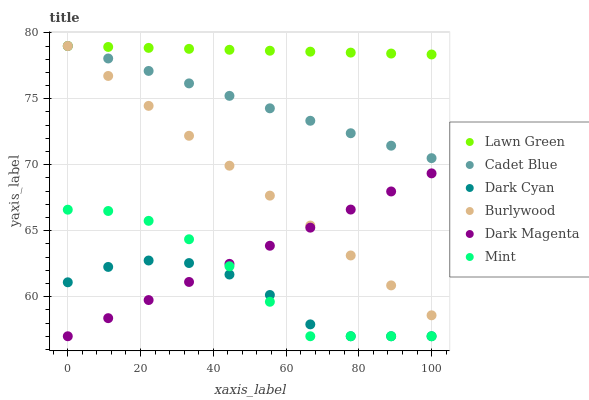Does Dark Cyan have the minimum area under the curve?
Answer yes or no. Yes. Does Lawn Green have the maximum area under the curve?
Answer yes or no. Yes. Does Cadet Blue have the minimum area under the curve?
Answer yes or no. No. Does Cadet Blue have the maximum area under the curve?
Answer yes or no. No. Is Dark Magenta the smoothest?
Answer yes or no. Yes. Is Dark Cyan the roughest?
Answer yes or no. Yes. Is Cadet Blue the smoothest?
Answer yes or no. No. Is Cadet Blue the roughest?
Answer yes or no. No. Does Dark Magenta have the lowest value?
Answer yes or no. Yes. Does Cadet Blue have the lowest value?
Answer yes or no. No. Does Burlywood have the highest value?
Answer yes or no. Yes. Does Dark Magenta have the highest value?
Answer yes or no. No. Is Mint less than Lawn Green?
Answer yes or no. Yes. Is Lawn Green greater than Dark Cyan?
Answer yes or no. Yes. Does Mint intersect Dark Magenta?
Answer yes or no. Yes. Is Mint less than Dark Magenta?
Answer yes or no. No. Is Mint greater than Dark Magenta?
Answer yes or no. No. Does Mint intersect Lawn Green?
Answer yes or no. No. 